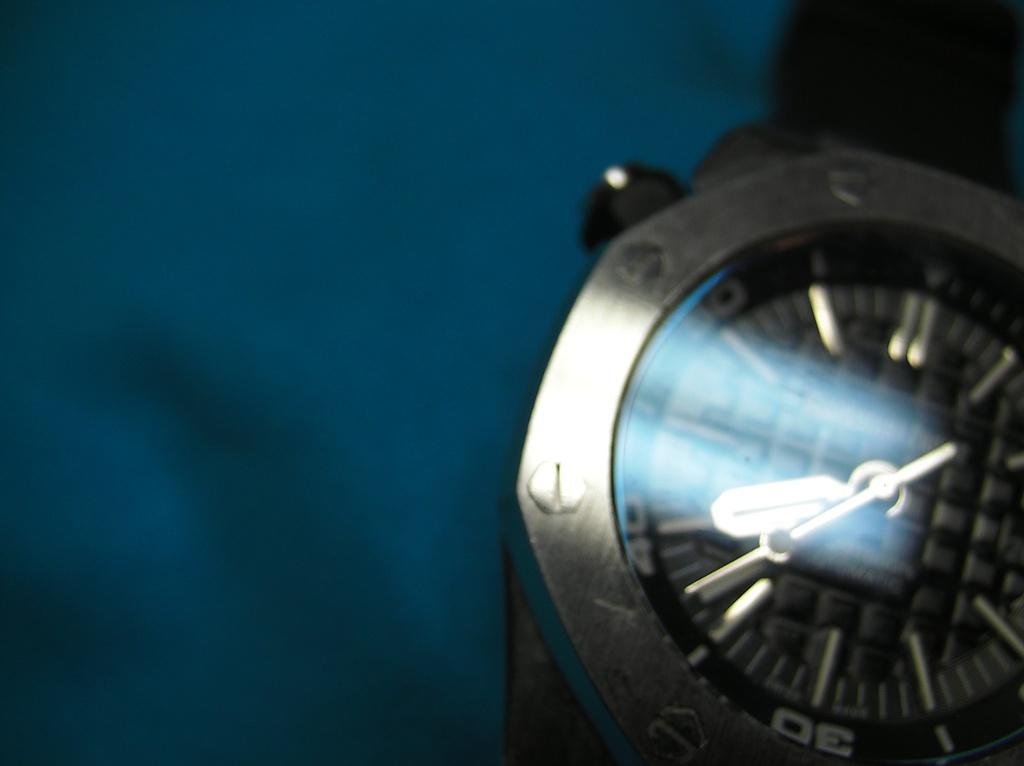<image>
Provide a brief description of the given image. A men's analog chronograph watch showing some of its numerals and a time of about 8 o'clock. 